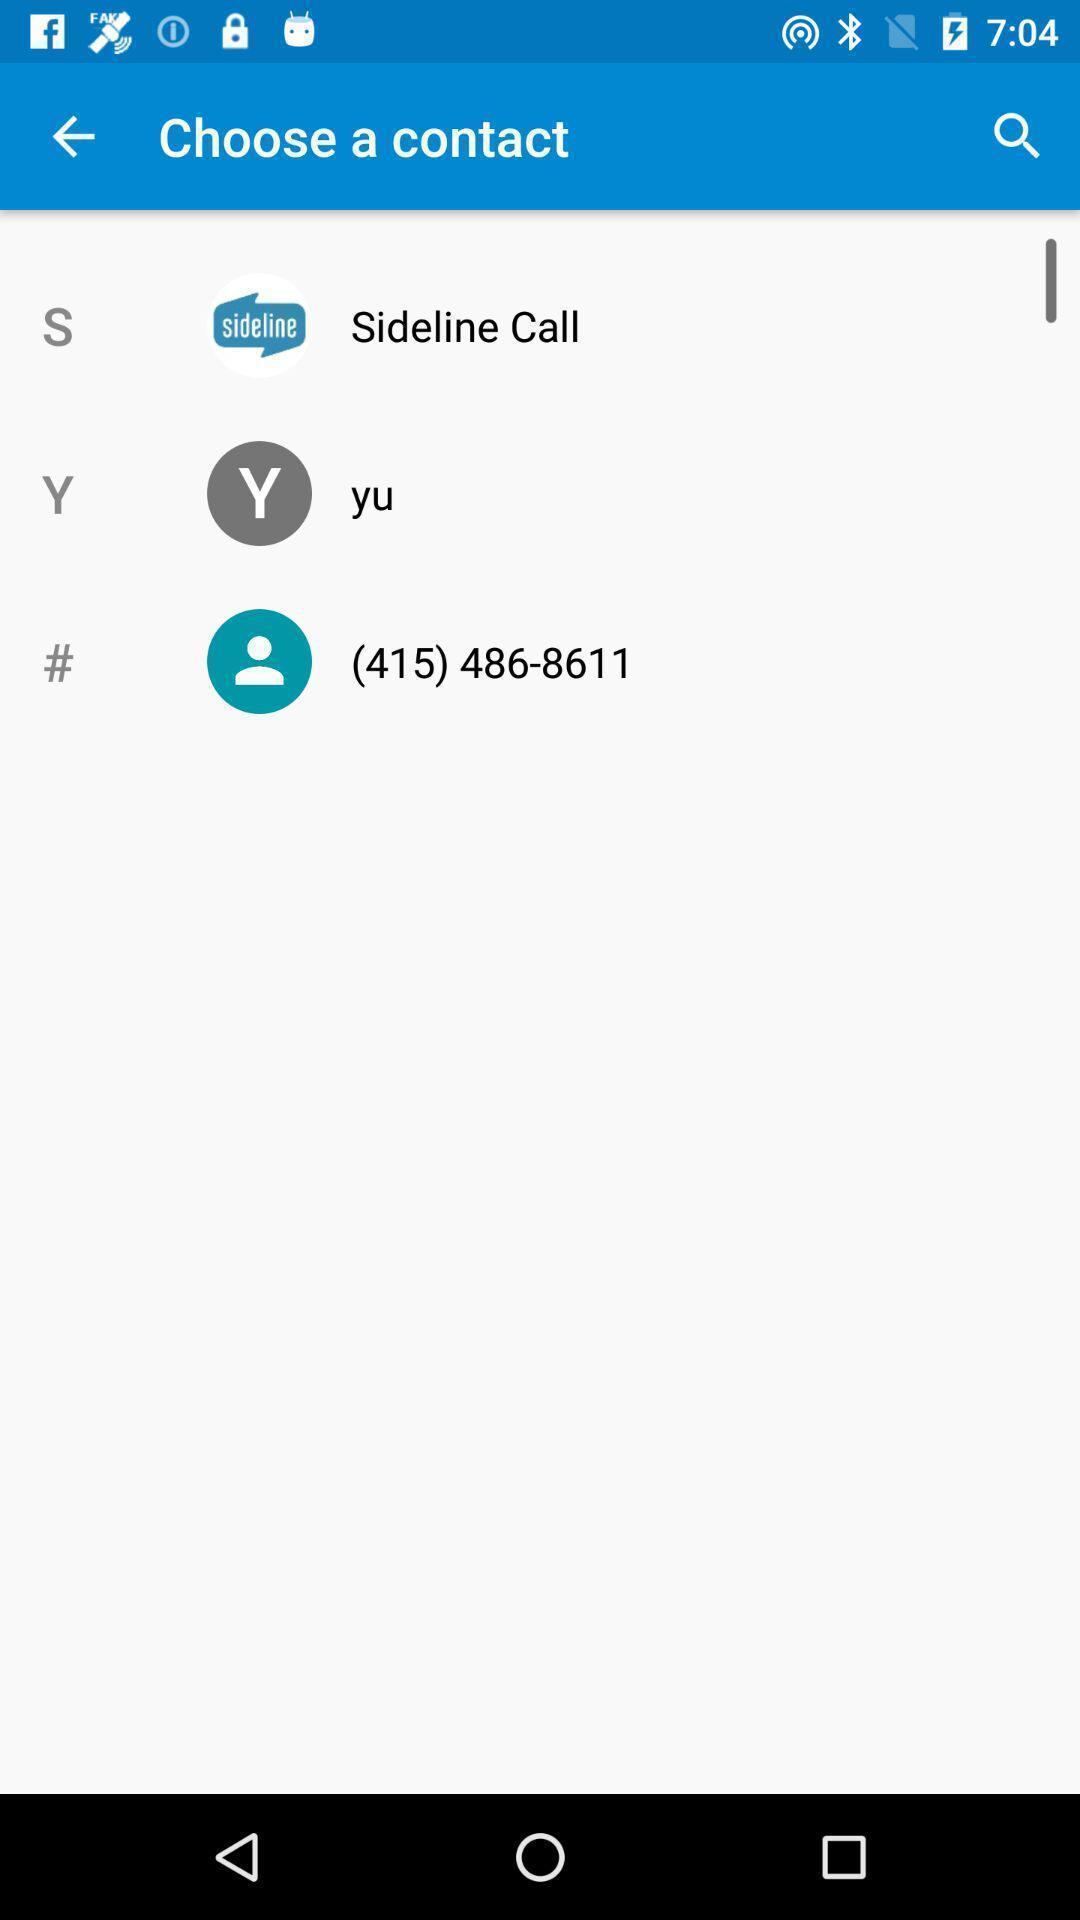Provide a textual representation of this image. Page showing the list of contacts to choose. 